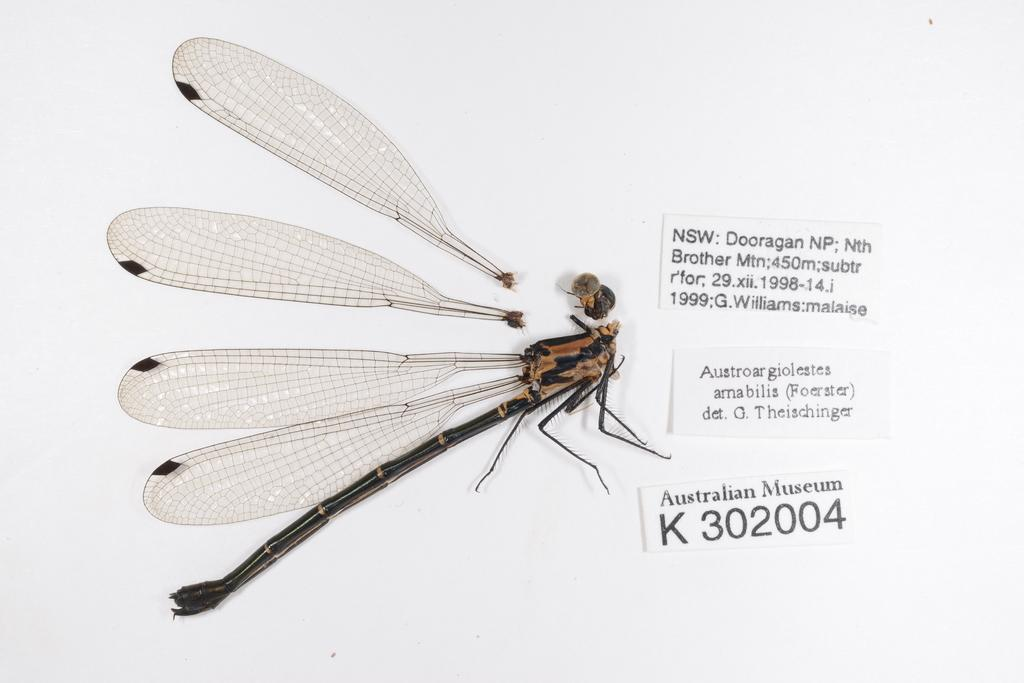What is the main subject in the center of the image? There is an insect in the center of the image. What else can be seen in the image besides the insect? There are papers with text in the image. What type of pan is being used for the activity in the image? There is no pan or activity present in the image; it only features an insect and papers with text. 